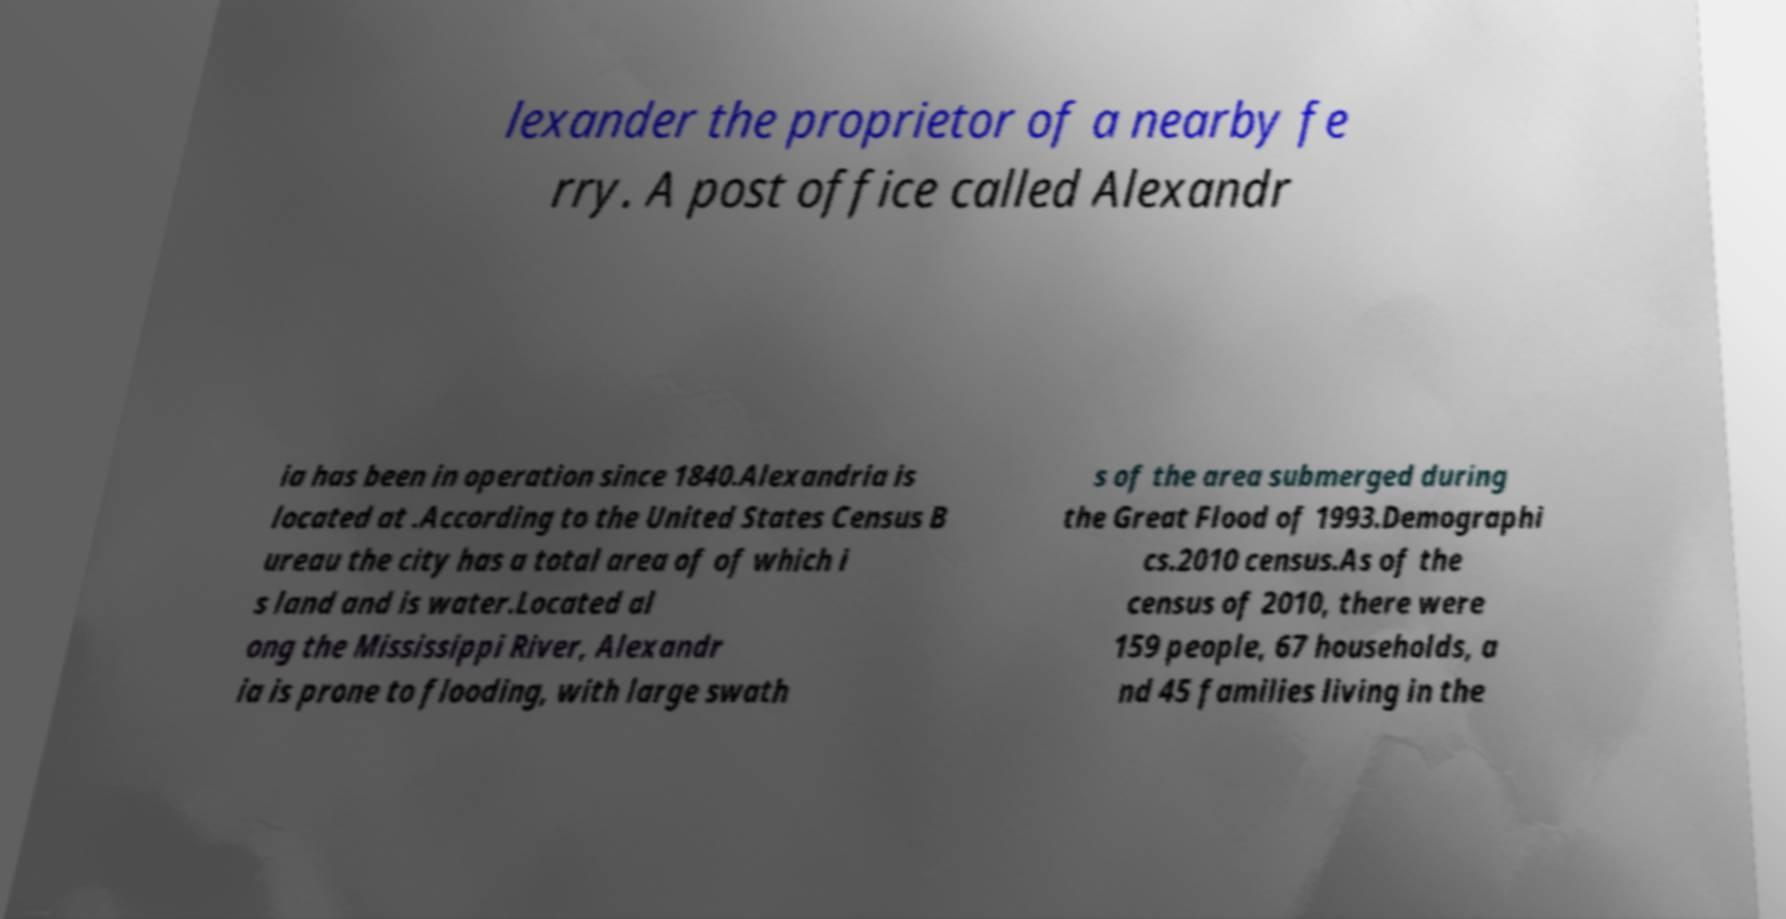Can you read and provide the text displayed in the image?This photo seems to have some interesting text. Can you extract and type it out for me? lexander the proprietor of a nearby fe rry. A post office called Alexandr ia has been in operation since 1840.Alexandria is located at .According to the United States Census B ureau the city has a total area of of which i s land and is water.Located al ong the Mississippi River, Alexandr ia is prone to flooding, with large swath s of the area submerged during the Great Flood of 1993.Demographi cs.2010 census.As of the census of 2010, there were 159 people, 67 households, a nd 45 families living in the 